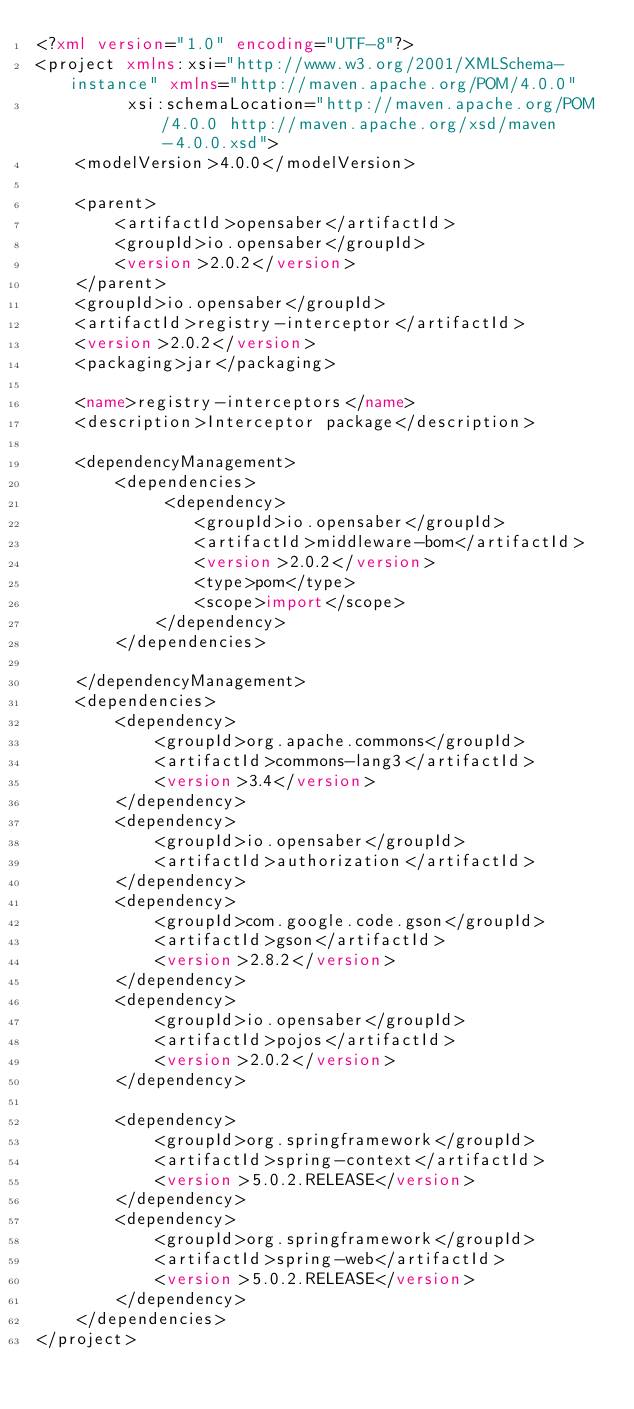Convert code to text. <code><loc_0><loc_0><loc_500><loc_500><_XML_><?xml version="1.0" encoding="UTF-8"?>
<project xmlns:xsi="http://www.w3.org/2001/XMLSchema-instance" xmlns="http://maven.apache.org/POM/4.0.0"
         xsi:schemaLocation="http://maven.apache.org/POM/4.0.0 http://maven.apache.org/xsd/maven-4.0.0.xsd">
    <modelVersion>4.0.0</modelVersion>

    <parent>
        <artifactId>opensaber</artifactId>
        <groupId>io.opensaber</groupId>
        <version>2.0.2</version>
    </parent>
    <groupId>io.opensaber</groupId>
    <artifactId>registry-interceptor</artifactId>
    <version>2.0.2</version>
    <packaging>jar</packaging>

    <name>registry-interceptors</name>
    <description>Interceptor package</description>

    <dependencyManagement>
        <dependencies>
             <dependency>
                <groupId>io.opensaber</groupId>
                <artifactId>middleware-bom</artifactId>
                <version>2.0.2</version>
                <type>pom</type>
                <scope>import</scope>
            </dependency> 
        </dependencies>

    </dependencyManagement>
    <dependencies>
        <dependency>
            <groupId>org.apache.commons</groupId>
            <artifactId>commons-lang3</artifactId>
            <version>3.4</version>
        </dependency>
        <dependency>
            <groupId>io.opensaber</groupId>
            <artifactId>authorization</artifactId>
        </dependency>
        <dependency>
            <groupId>com.google.code.gson</groupId>
            <artifactId>gson</artifactId>
            <version>2.8.2</version>
        </dependency>
        <dependency>
            <groupId>io.opensaber</groupId>
            <artifactId>pojos</artifactId>
            <version>2.0.2</version>
        </dependency>
        
        <dependency>
            <groupId>org.springframework</groupId>
            <artifactId>spring-context</artifactId>
            <version>5.0.2.RELEASE</version>
        </dependency>
        <dependency>
            <groupId>org.springframework</groupId>
            <artifactId>spring-web</artifactId>
            <version>5.0.2.RELEASE</version>
        </dependency>
    </dependencies>
</project>
</code> 